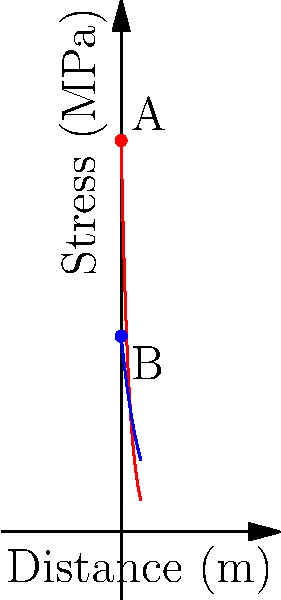A curved composite material surface is subjected to a non-uniform stress distribution. The stress $\sigma$ (in MPa) on the outer and inner surfaces varies with distance $x$ (in meters) according to the following equations:

Outer surface: $\sigma_o(x) = 100e^{-0.5x}$
Inner surface: $\sigma_i(x) = 50e^{-0.2x}$

Calculate the total stress difference $\Delta\sigma$ between points A and B on the outer and inner surfaces at $x = 0$, and determine at what distance $x$ this stress difference reduces to 25% of its initial value. Let's approach this problem step-by-step:

1) First, calculate the stress difference $\Delta\sigma$ at $x = 0$:
   
   At $x = 0$:
   $\sigma_o(0) = 100e^{-0.5(0)} = 100$ MPa
   $\sigma_i(0) = 50e^{-0.2(0)} = 50$ MPa
   
   $\Delta\sigma = \sigma_o(0) - \sigma_i(0) = 100 - 50 = 50$ MPa

2) Now, we need to find $x$ where $\Delta\sigma(x) = 0.25 \Delta\sigma(0)$:

   $\Delta\sigma(x) = \sigma_o(x) - \sigma_i(x) = 100e^{-0.5x} - 50e^{-0.2x}$
   
   We want to solve: $100e^{-0.5x} - 50e^{-0.2x} = 0.25(50) = 12.5$

3) This equation can't be solved algebraically. We need to use numerical methods or graphical solution. Using a numerical solver, we find:

   $x \approx 3.22$ m

4) We can verify:
   At $x = 3.22$:
   $\sigma_o(3.22) \approx 20.33$ MPa
   $\sigma_i(3.22) \approx 7.83$ MPa
   
   $\Delta\sigma(3.22) = 20.33 - 7.83 = 12.5$ MPa

   Indeed, this is 25% of the initial stress difference of 50 MPa.
Answer: $\Delta\sigma(0) = 50$ MPa; $x \approx 3.22$ m 